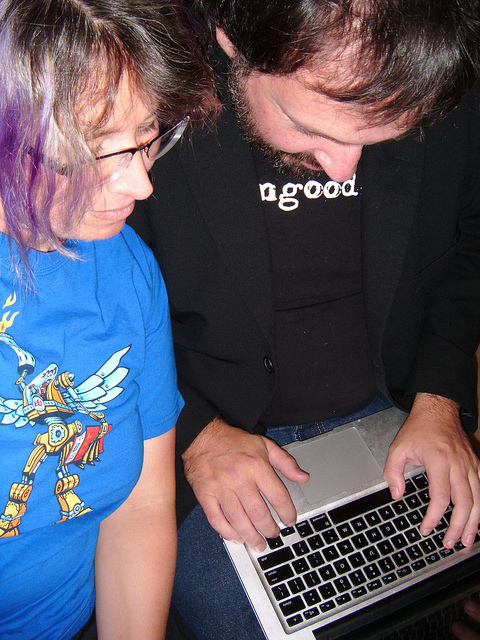Please transcribe the text in this image. a good 